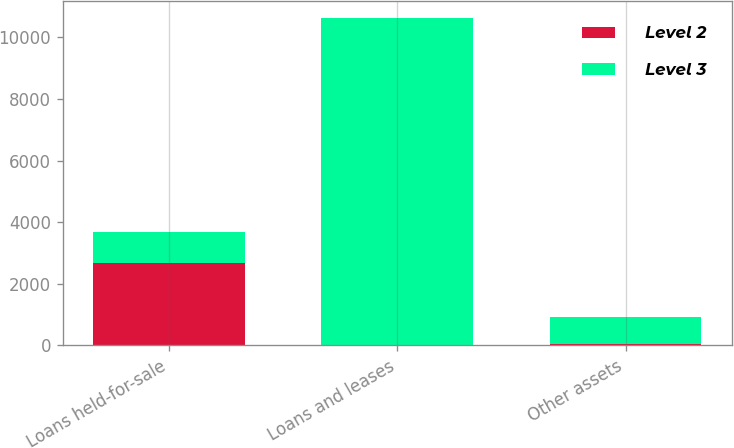Convert chart. <chart><loc_0><loc_0><loc_500><loc_500><stacked_bar_chart><ecel><fcel>Loans held-for-sale<fcel>Loans and leases<fcel>Other assets<nl><fcel>Level 2<fcel>2662<fcel>9<fcel>44<nl><fcel>Level 3<fcel>1008<fcel>10629<fcel>885<nl></chart> 